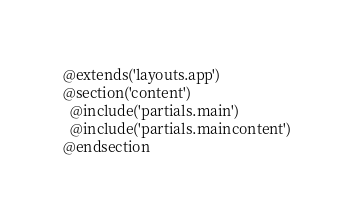Convert code to text. <code><loc_0><loc_0><loc_500><loc_500><_PHP_>@extends('layouts.app')
@section('content')
  @include('partials.main')
  @include('partials.maincontent')
@endsection</code> 